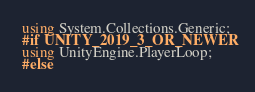<code> <loc_0><loc_0><loc_500><loc_500><_C#_>using System.Collections.Generic;
#if UNITY_2019_3_OR_NEWER
using UnityEngine.PlayerLoop;
#else</code> 